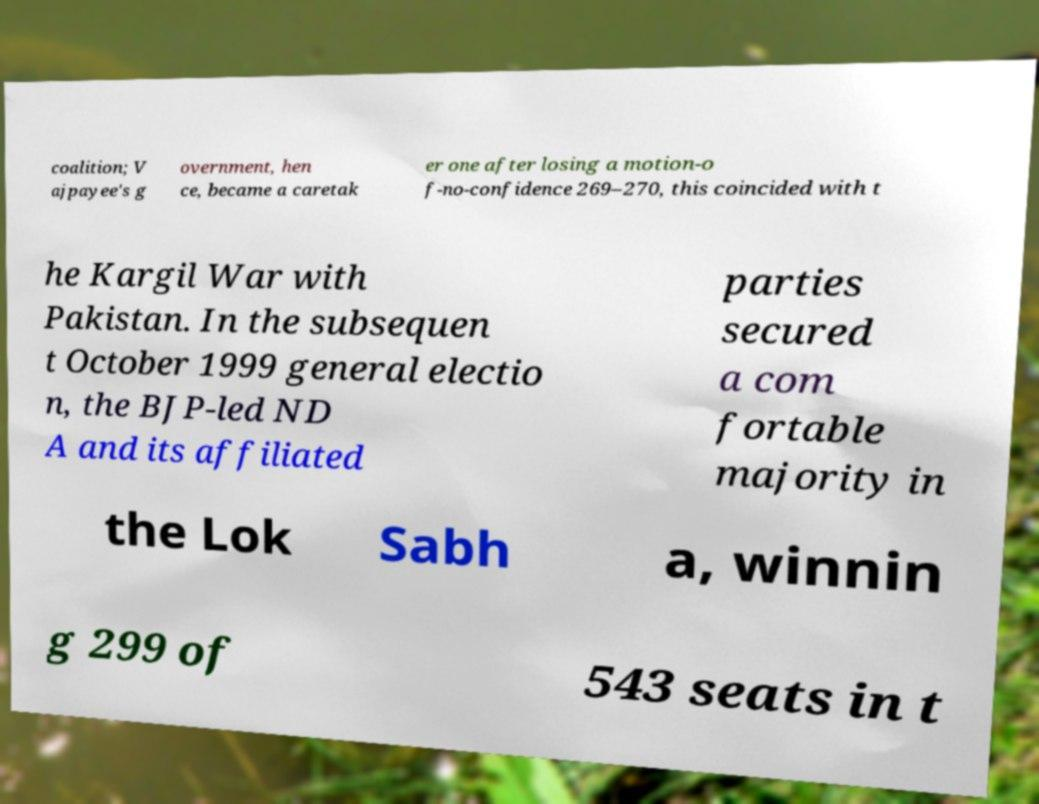Can you accurately transcribe the text from the provided image for me? coalition; V ajpayee's g overnment, hen ce, became a caretak er one after losing a motion-o f-no-confidence 269–270, this coincided with t he Kargil War with Pakistan. In the subsequen t October 1999 general electio n, the BJP-led ND A and its affiliated parties secured a com fortable majority in the Lok Sabh a, winnin g 299 of 543 seats in t 